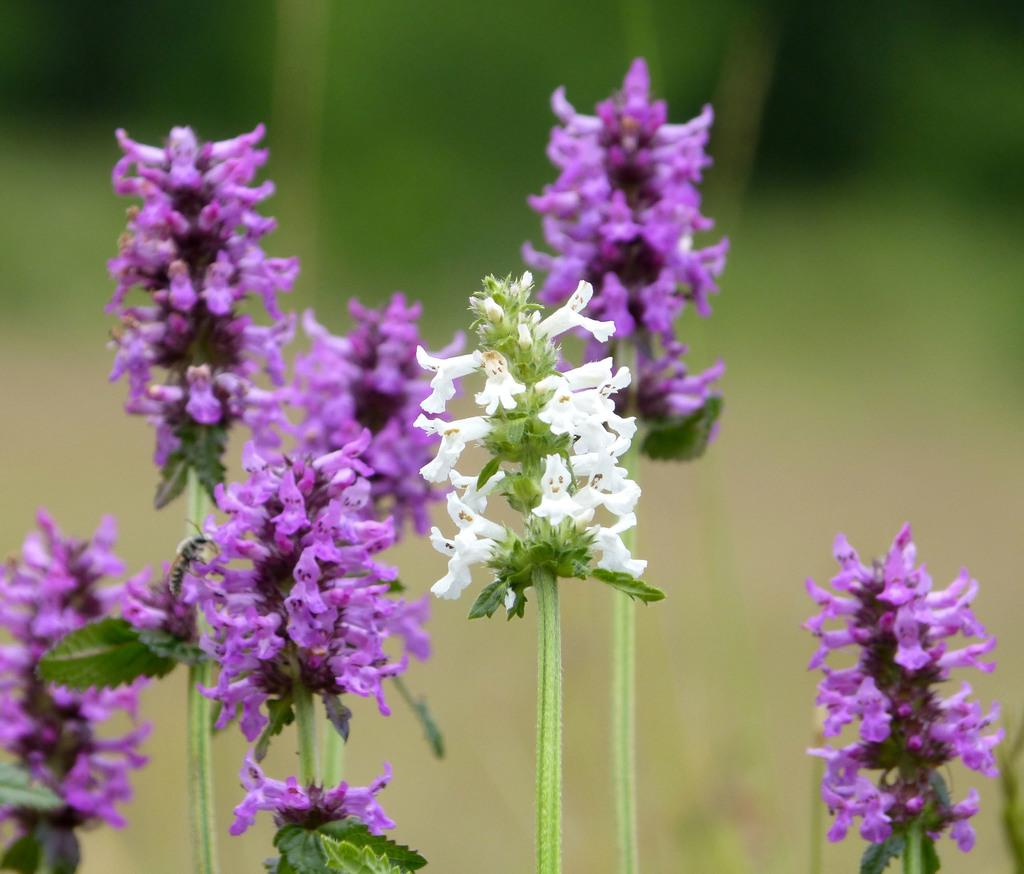What type of plants can be seen in the image? There are flowers in the image. Can you describe the background of the image? The background of the image is blurry. What type of territory is being claimed by the flowers in the image? There is no indication of territory being claimed in the image, as it features flowers and a blurry background. 